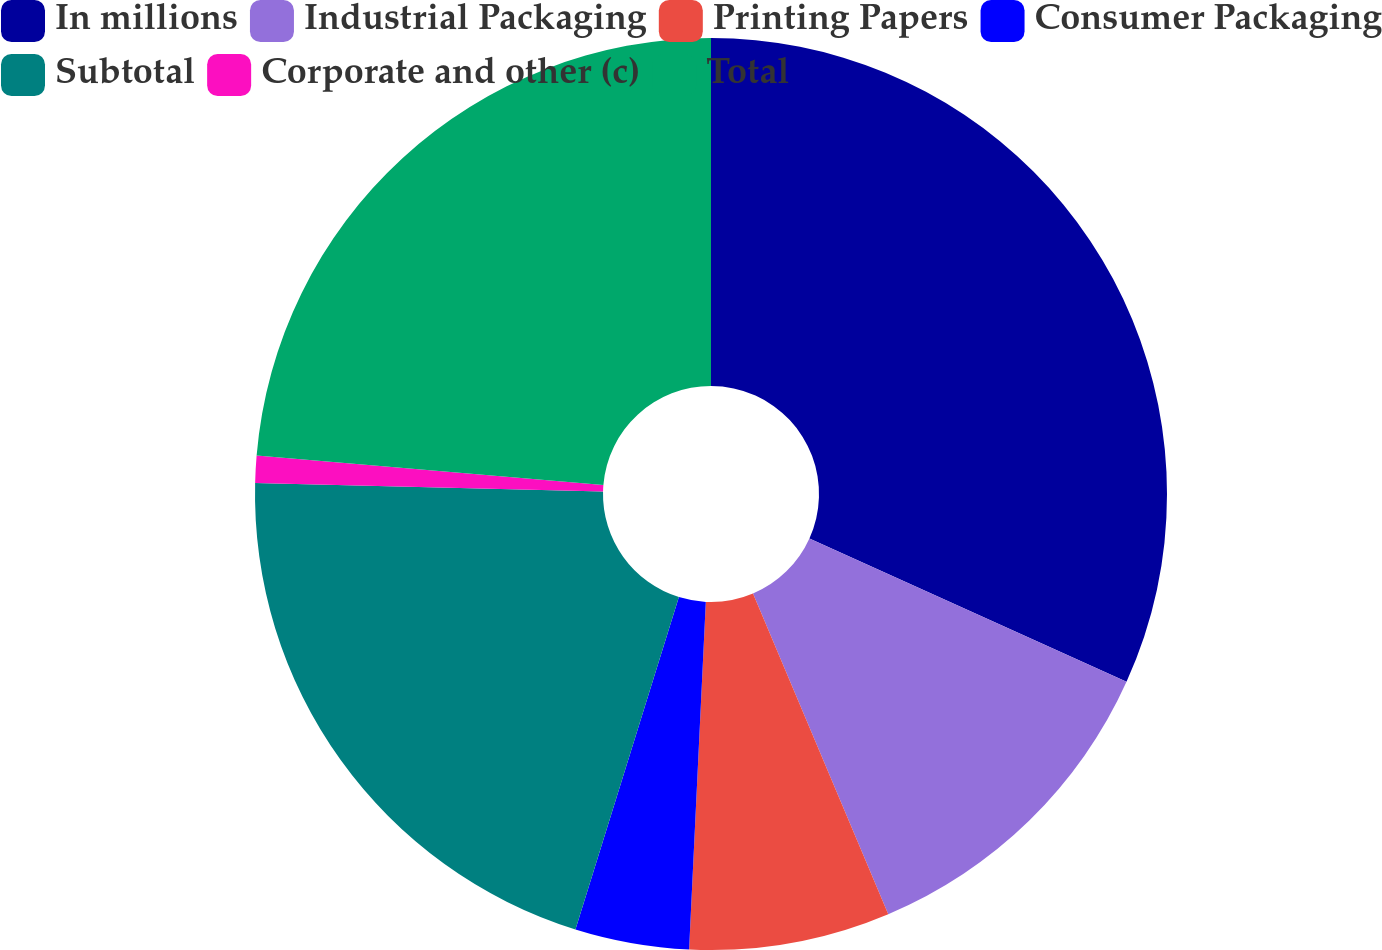Convert chart to OTSL. <chart><loc_0><loc_0><loc_500><loc_500><pie_chart><fcel>In millions<fcel>Industrial Packaging<fcel>Printing Papers<fcel>Consumer Packaging<fcel>Subtotal<fcel>Corporate and other (c)<fcel>Total<nl><fcel>31.76%<fcel>11.89%<fcel>7.12%<fcel>4.04%<fcel>20.58%<fcel>0.96%<fcel>23.66%<nl></chart> 